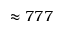<formula> <loc_0><loc_0><loc_500><loc_500>\approx 7 7 7</formula> 